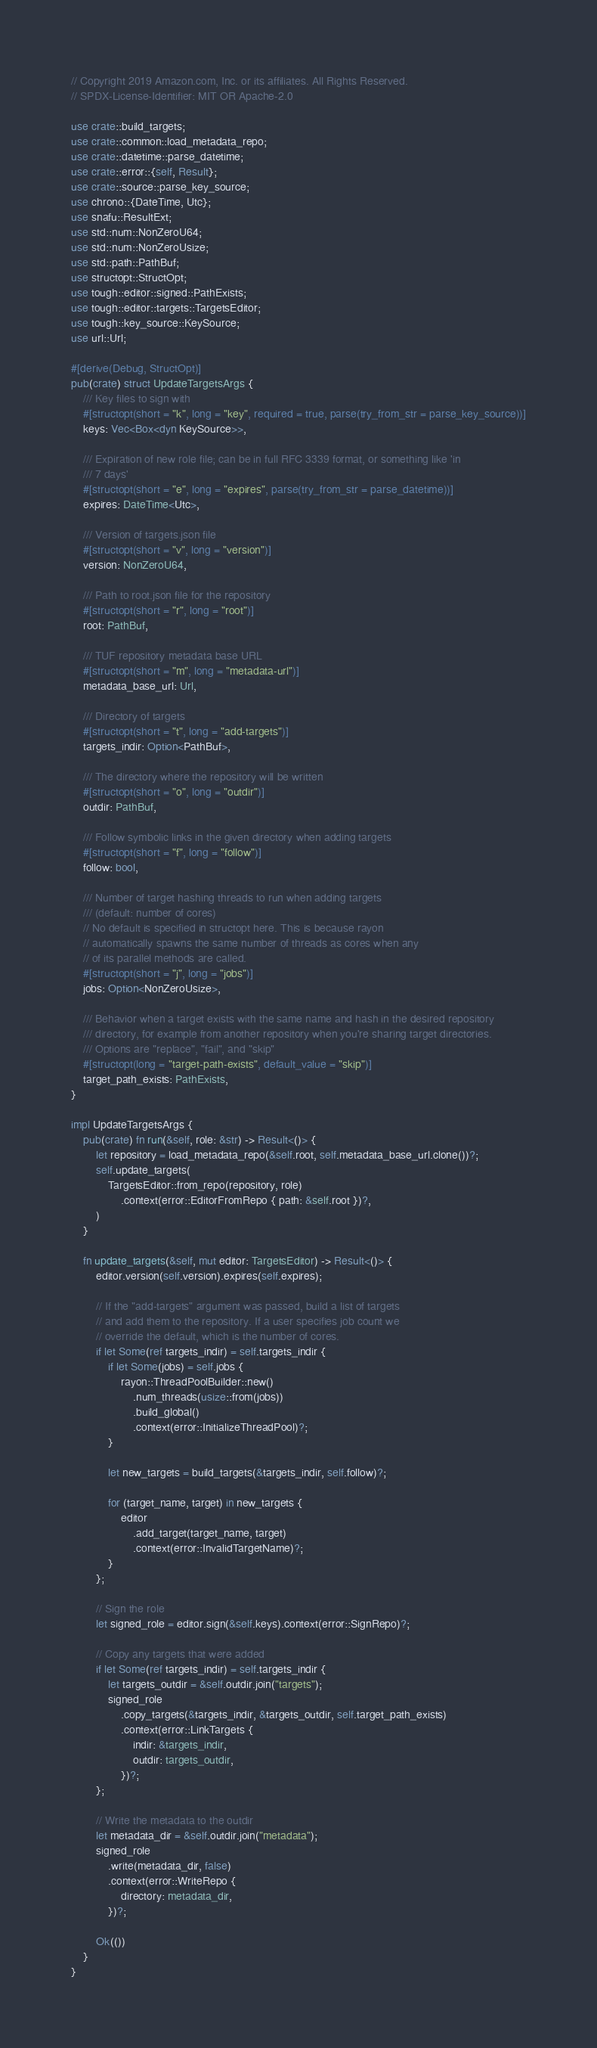<code> <loc_0><loc_0><loc_500><loc_500><_Rust_>// Copyright 2019 Amazon.com, Inc. or its affiliates. All Rights Reserved.
// SPDX-License-Identifier: MIT OR Apache-2.0

use crate::build_targets;
use crate::common::load_metadata_repo;
use crate::datetime::parse_datetime;
use crate::error::{self, Result};
use crate::source::parse_key_source;
use chrono::{DateTime, Utc};
use snafu::ResultExt;
use std::num::NonZeroU64;
use std::num::NonZeroUsize;
use std::path::PathBuf;
use structopt::StructOpt;
use tough::editor::signed::PathExists;
use tough::editor::targets::TargetsEditor;
use tough::key_source::KeySource;
use url::Url;

#[derive(Debug, StructOpt)]
pub(crate) struct UpdateTargetsArgs {
    /// Key files to sign with
    #[structopt(short = "k", long = "key", required = true, parse(try_from_str = parse_key_source))]
    keys: Vec<Box<dyn KeySource>>,

    /// Expiration of new role file; can be in full RFC 3339 format, or something like 'in
    /// 7 days'
    #[structopt(short = "e", long = "expires", parse(try_from_str = parse_datetime))]
    expires: DateTime<Utc>,

    /// Version of targets.json file
    #[structopt(short = "v", long = "version")]
    version: NonZeroU64,

    /// Path to root.json file for the repository
    #[structopt(short = "r", long = "root")]
    root: PathBuf,

    /// TUF repository metadata base URL
    #[structopt(short = "m", long = "metadata-url")]
    metadata_base_url: Url,

    /// Directory of targets
    #[structopt(short = "t", long = "add-targets")]
    targets_indir: Option<PathBuf>,

    /// The directory where the repository will be written
    #[structopt(short = "o", long = "outdir")]
    outdir: PathBuf,

    /// Follow symbolic links in the given directory when adding targets
    #[structopt(short = "f", long = "follow")]
    follow: bool,

    /// Number of target hashing threads to run when adding targets
    /// (default: number of cores)
    // No default is specified in structopt here. This is because rayon
    // automatically spawns the same number of threads as cores when any
    // of its parallel methods are called.
    #[structopt(short = "j", long = "jobs")]
    jobs: Option<NonZeroUsize>,

    /// Behavior when a target exists with the same name and hash in the desired repository
    /// directory, for example from another repository when you're sharing target directories.
    /// Options are "replace", "fail", and "skip"
    #[structopt(long = "target-path-exists", default_value = "skip")]
    target_path_exists: PathExists,
}

impl UpdateTargetsArgs {
    pub(crate) fn run(&self, role: &str) -> Result<()> {
        let repository = load_metadata_repo(&self.root, self.metadata_base_url.clone())?;
        self.update_targets(
            TargetsEditor::from_repo(repository, role)
                .context(error::EditorFromRepo { path: &self.root })?,
        )
    }

    fn update_targets(&self, mut editor: TargetsEditor) -> Result<()> {
        editor.version(self.version).expires(self.expires);

        // If the "add-targets" argument was passed, build a list of targets
        // and add them to the repository. If a user specifies job count we
        // override the default, which is the number of cores.
        if let Some(ref targets_indir) = self.targets_indir {
            if let Some(jobs) = self.jobs {
                rayon::ThreadPoolBuilder::new()
                    .num_threads(usize::from(jobs))
                    .build_global()
                    .context(error::InitializeThreadPool)?;
            }

            let new_targets = build_targets(&targets_indir, self.follow)?;

            for (target_name, target) in new_targets {
                editor
                    .add_target(target_name, target)
                    .context(error::InvalidTargetName)?;
            }
        };

        // Sign the role
        let signed_role = editor.sign(&self.keys).context(error::SignRepo)?;

        // Copy any targets that were added
        if let Some(ref targets_indir) = self.targets_indir {
            let targets_outdir = &self.outdir.join("targets");
            signed_role
                .copy_targets(&targets_indir, &targets_outdir, self.target_path_exists)
                .context(error::LinkTargets {
                    indir: &targets_indir,
                    outdir: targets_outdir,
                })?;
        };

        // Write the metadata to the outdir
        let metadata_dir = &self.outdir.join("metadata");
        signed_role
            .write(metadata_dir, false)
            .context(error::WriteRepo {
                directory: metadata_dir,
            })?;

        Ok(())
    }
}
</code> 